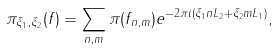Convert formula to latex. <formula><loc_0><loc_0><loc_500><loc_500>\pi _ { \xi _ { 1 } , \xi _ { 2 } } ( f ) = \sum _ { n , m } \pi ( f _ { n , m } ) e ^ { - 2 \pi i ( \xi _ { 1 } n L _ { 2 } + \xi _ { 2 } m L _ { 1 } ) } ,</formula> 